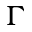Convert formula to latex. <formula><loc_0><loc_0><loc_500><loc_500>\Gamma</formula> 